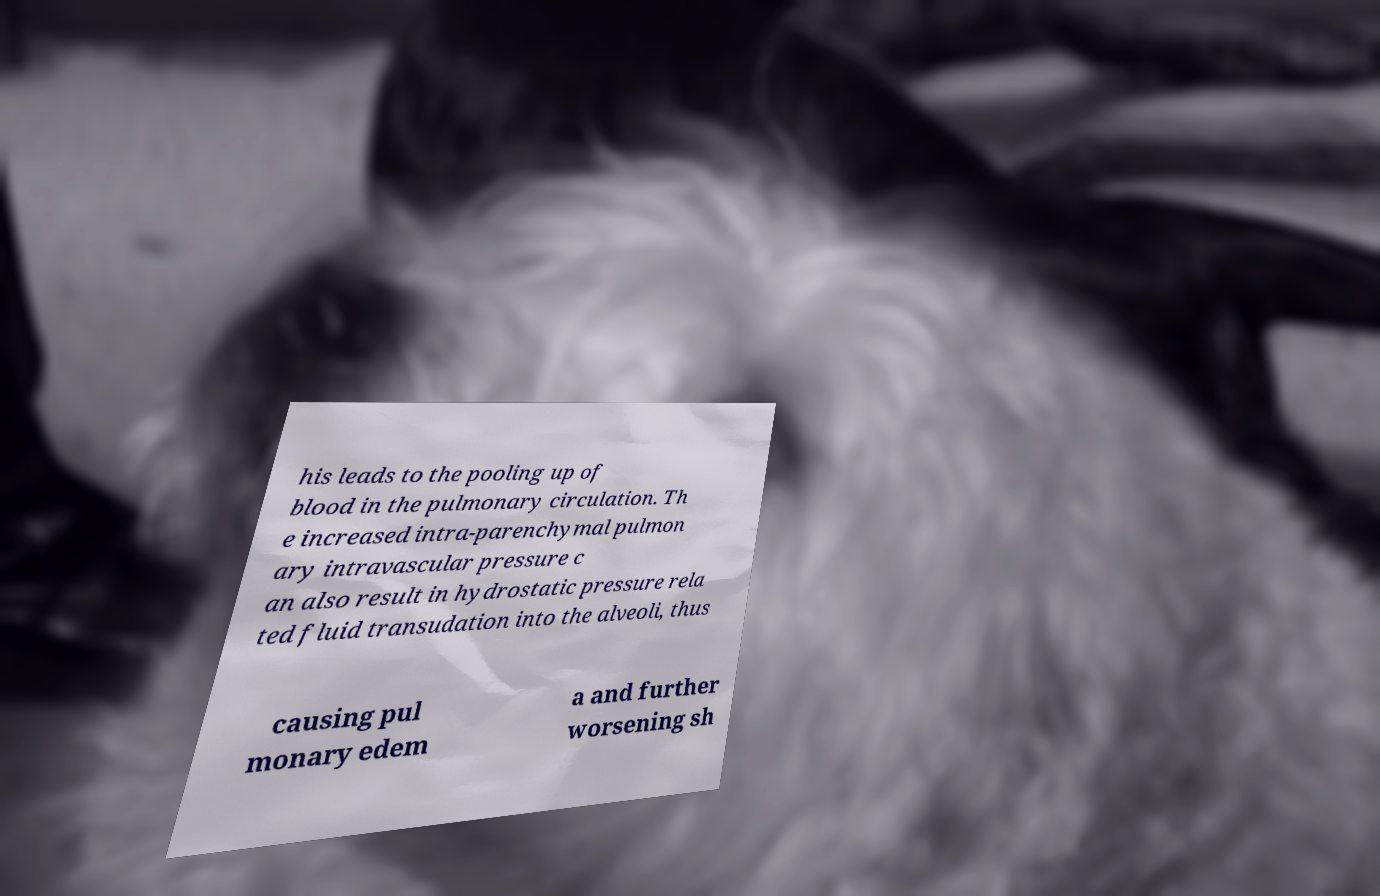Can you accurately transcribe the text from the provided image for me? his leads to the pooling up of blood in the pulmonary circulation. Th e increased intra-parenchymal pulmon ary intravascular pressure c an also result in hydrostatic pressure rela ted fluid transudation into the alveoli, thus causing pul monary edem a and further worsening sh 